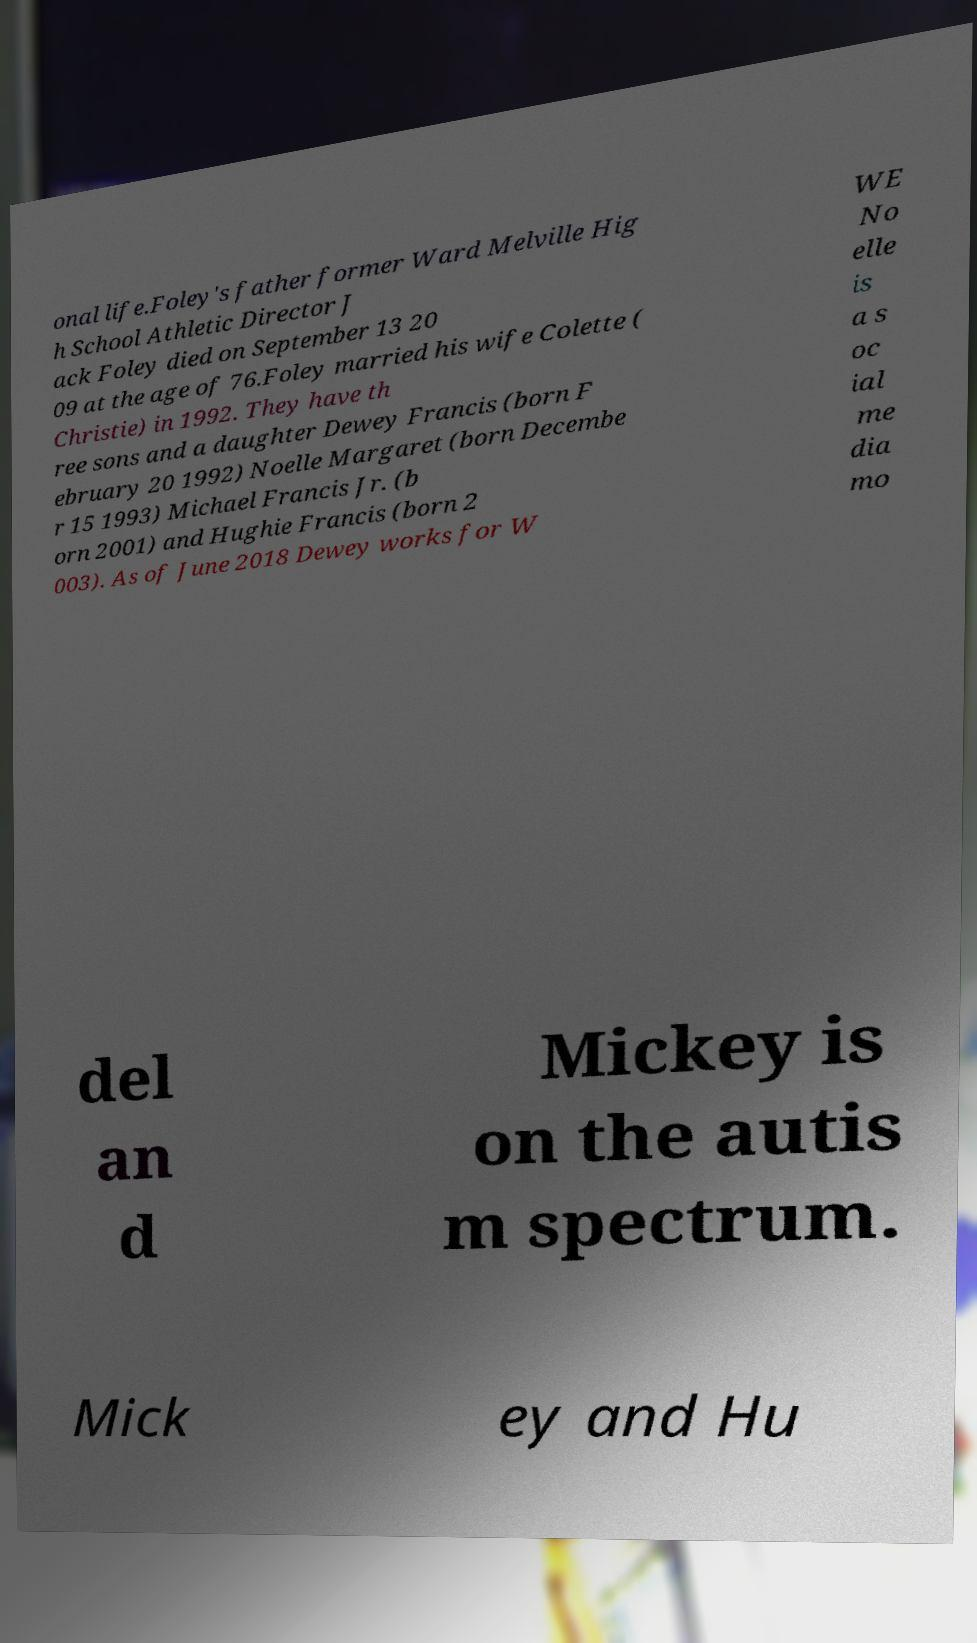Could you extract and type out the text from this image? onal life.Foley's father former Ward Melville Hig h School Athletic Director J ack Foley died on September 13 20 09 at the age of 76.Foley married his wife Colette ( Christie) in 1992. They have th ree sons and a daughter Dewey Francis (born F ebruary 20 1992) Noelle Margaret (born Decembe r 15 1993) Michael Francis Jr. (b orn 2001) and Hughie Francis (born 2 003). As of June 2018 Dewey works for W WE No elle is a s oc ial me dia mo del an d Mickey is on the autis m spectrum. Mick ey and Hu 